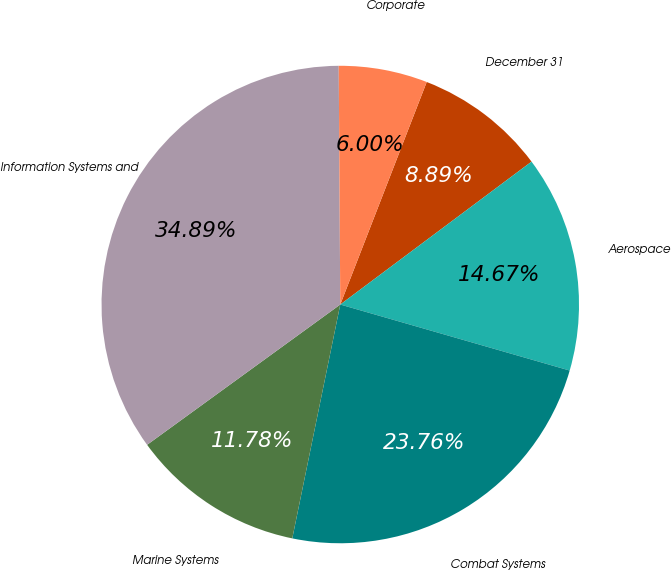Convert chart. <chart><loc_0><loc_0><loc_500><loc_500><pie_chart><fcel>December 31<fcel>Aerospace<fcel>Combat Systems<fcel>Marine Systems<fcel>Information Systems and<fcel>Corporate<nl><fcel>8.89%<fcel>14.67%<fcel>23.76%<fcel>11.78%<fcel>34.89%<fcel>6.0%<nl></chart> 